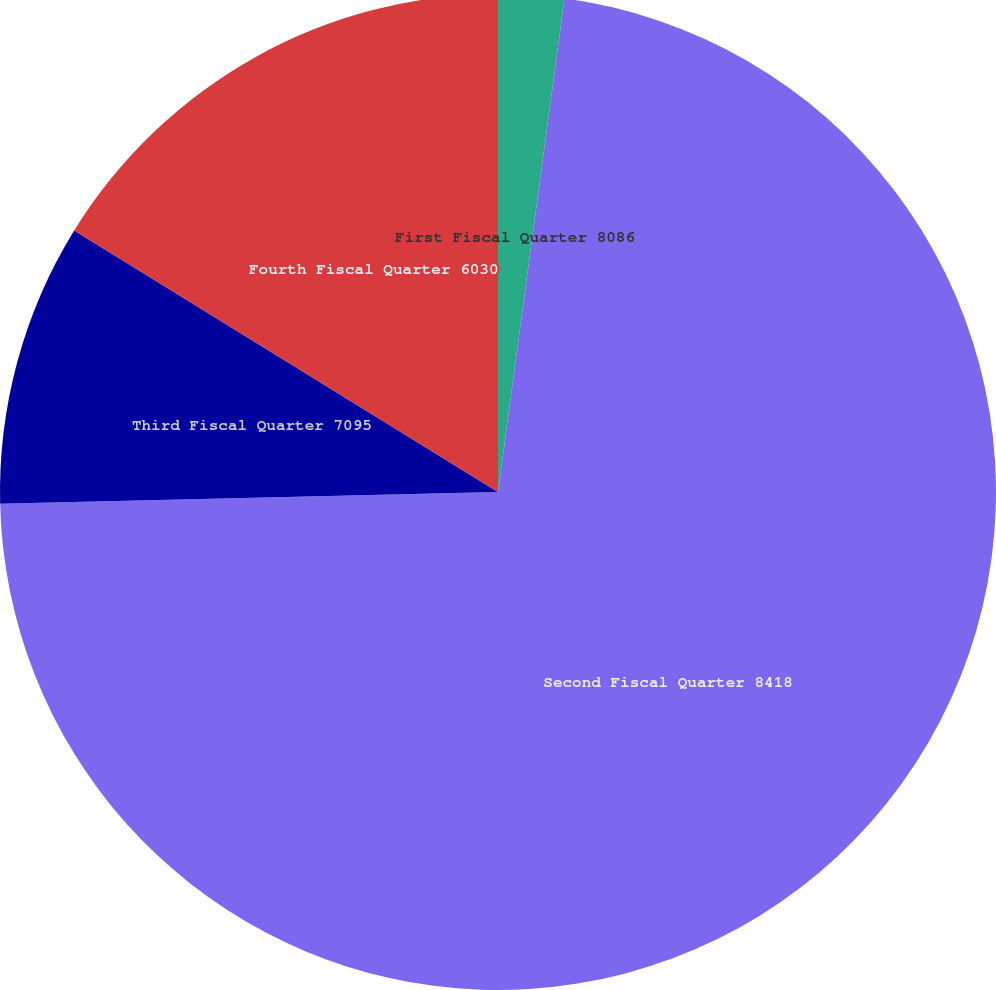<chart> <loc_0><loc_0><loc_500><loc_500><pie_chart><fcel>First Fiscal Quarter 8086<fcel>Second Fiscal Quarter 8418<fcel>Third Fiscal Quarter 7095<fcel>Fourth Fiscal Quarter 6030<nl><fcel>2.13%<fcel>72.49%<fcel>9.17%<fcel>16.2%<nl></chart> 